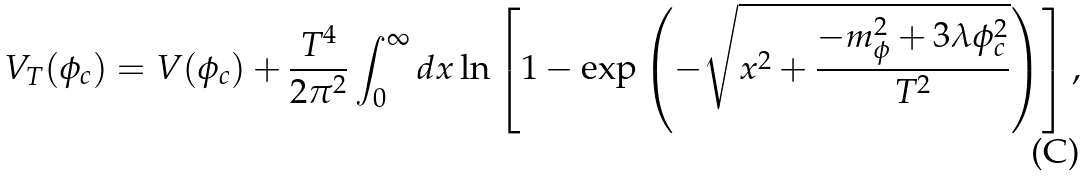<formula> <loc_0><loc_0><loc_500><loc_500>V _ { T } ( \phi _ { c } ) = V ( \phi _ { c } ) + \frac { T ^ { 4 } } { 2 \pi ^ { 2 } } \int ^ { \infty } _ { 0 } d x \ln \left [ 1 - \exp \left ( - \sqrt { x ^ { 2 } + \frac { - m _ { \phi } ^ { 2 } + 3 \lambda \phi _ { c } ^ { 2 } } { T ^ { 2 } } } \right ) \right ] ,</formula> 